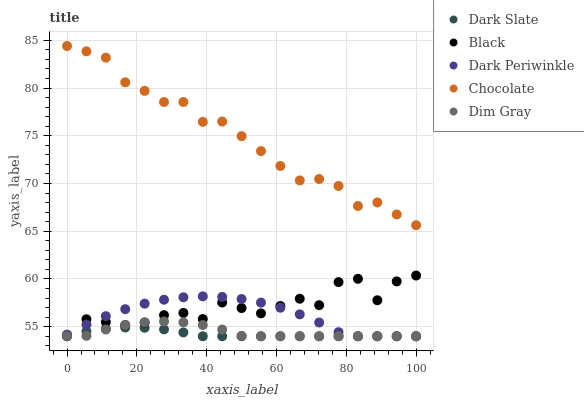Does Dark Slate have the minimum area under the curve?
Answer yes or no. Yes. Does Chocolate have the maximum area under the curve?
Answer yes or no. Yes. Does Dim Gray have the minimum area under the curve?
Answer yes or no. No. Does Dim Gray have the maximum area under the curve?
Answer yes or no. No. Is Dark Slate the smoothest?
Answer yes or no. Yes. Is Black the roughest?
Answer yes or no. Yes. Is Dim Gray the smoothest?
Answer yes or no. No. Is Dim Gray the roughest?
Answer yes or no. No. Does Dark Slate have the lowest value?
Answer yes or no. Yes. Does Chocolate have the lowest value?
Answer yes or no. No. Does Chocolate have the highest value?
Answer yes or no. Yes. Does Dim Gray have the highest value?
Answer yes or no. No. Is Dark Slate less than Chocolate?
Answer yes or no. Yes. Is Chocolate greater than Dim Gray?
Answer yes or no. Yes. Does Dim Gray intersect Dark Slate?
Answer yes or no. Yes. Is Dim Gray less than Dark Slate?
Answer yes or no. No. Is Dim Gray greater than Dark Slate?
Answer yes or no. No. Does Dark Slate intersect Chocolate?
Answer yes or no. No. 